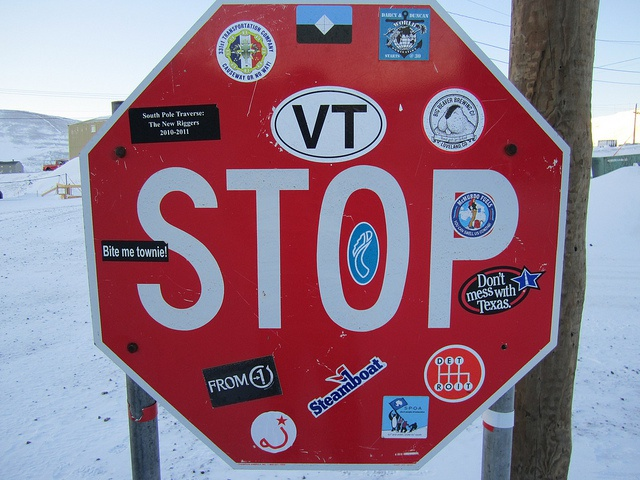Describe the objects in this image and their specific colors. I can see stop sign in lightblue, brown, darkgray, and black tones and truck in lightblue, brown, and darkgray tones in this image. 